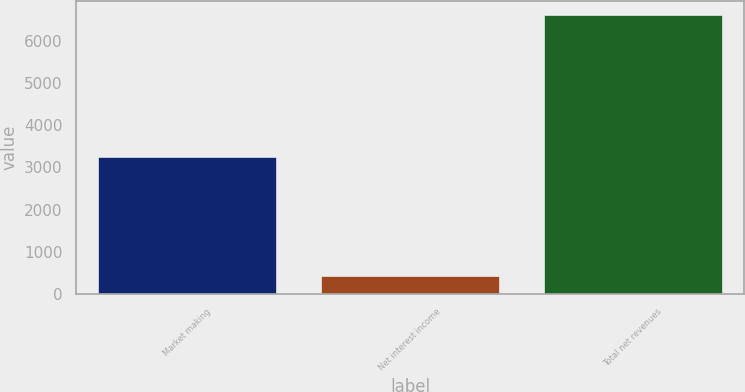Convert chart to OTSL. <chart><loc_0><loc_0><loc_500><loc_500><bar_chart><fcel>Market making<fcel>Net interest income<fcel>Total net revenues<nl><fcel>3257<fcel>426<fcel>6603<nl></chart> 